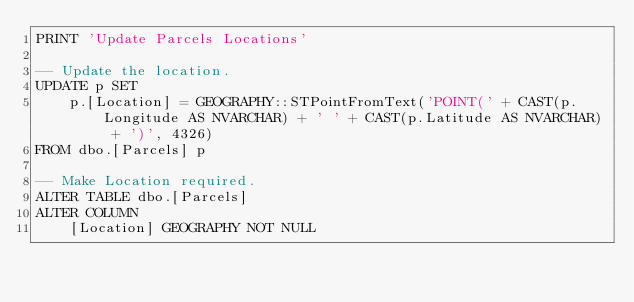<code> <loc_0><loc_0><loc_500><loc_500><_SQL_>PRINT 'Update Parcels Locations'

-- Update the location.
UPDATE p SET
    p.[Location] = GEOGRAPHY::STPointFromText('POINT(' + CAST(p.Longitude AS NVARCHAR) + ' ' + CAST(p.Latitude AS NVARCHAR) + ')', 4326)
FROM dbo.[Parcels] p

-- Make Location required.
ALTER TABLE dbo.[Parcels]
ALTER COLUMN
    [Location] GEOGRAPHY NOT NULL
</code> 